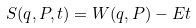<formula> <loc_0><loc_0><loc_500><loc_500>S ( q , P , t ) = W ( q , P ) - E t</formula> 